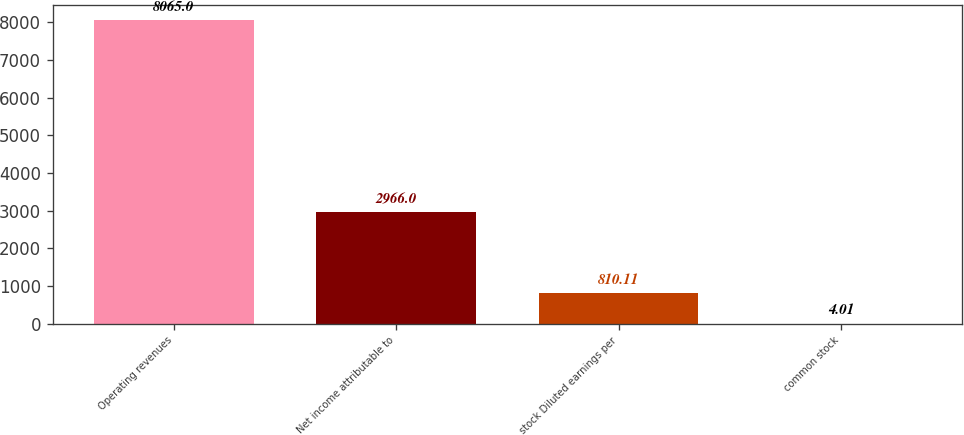Convert chart. <chart><loc_0><loc_0><loc_500><loc_500><bar_chart><fcel>Operating revenues<fcel>Net income attributable to<fcel>stock Diluted earnings per<fcel>common stock<nl><fcel>8065<fcel>2966<fcel>810.11<fcel>4.01<nl></chart> 